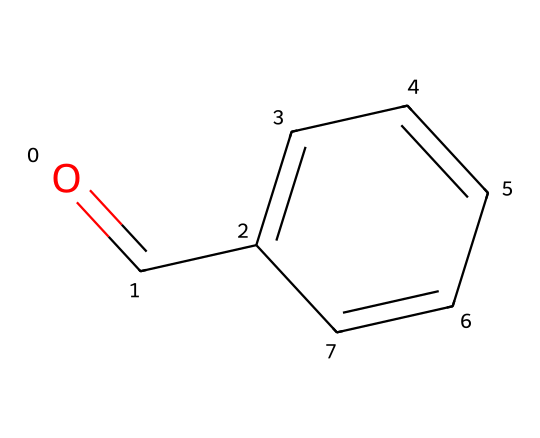What is the functional group present in benzaldehyde? The structure of benzaldehyde features a carbonyl group (C=O) directly bonded to a benzene ring, which identifies its functional group as an aldehyde.
Answer: aldehyde How many carbon atoms are in benzaldehyde? The SMILES representation indicates there are six carbon atoms in the benzene ring and one in the carbonyl group, totaling seven carbon atoms.
Answer: 7 What is the total number of hydrogen atoms in benzaldehyde? There are five hydrogen atoms on the benzene ring (due to one being replaced by the carbonyl group) plus one from the carbonyl’s aldehyde, resulting in a total of six hydrogen atoms.
Answer: 6 Is benzaldehyde a saturated or unsaturated compound? The presence of a carbon-carbon double bond in the benzene ring and a carbonyl group indicates that benzaldehyde is an unsaturated compound.
Answer: unsaturated What type of compound is benzaldehyde? Benzaldehyde has a benzene ring with a functional group, classifying it as an aromatic compound due to its stable cyclic structure and resonance.
Answer: aromatic What is the IUPAC name of the molecule represented by the SMILES? The SMILES indicates the presence of a formyl group attached to a benzene ring, which is named benzaldehyde in IUPAC nomenclature.
Answer: benzaldehyde 